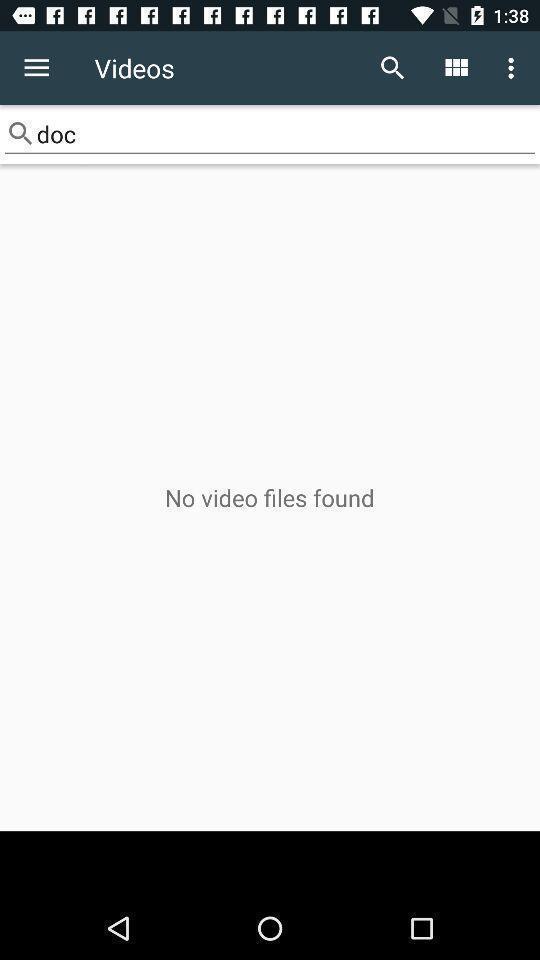Describe the visual elements of this screenshot. Page displaying information about file handling application. 